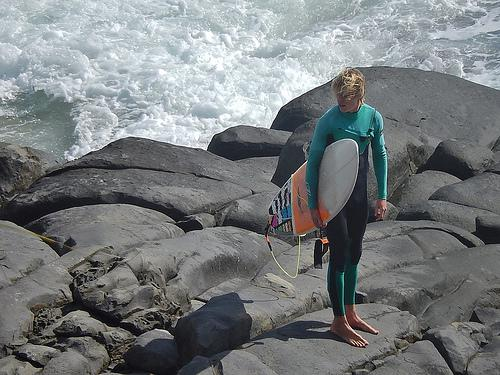Question: who is in the photo?
Choices:
A. The woman.
B. The man.
C. The children.
D. The dogs.
Answer with the letter. Answer: B Question: where is the man?
Choices:
A. On the rocks.
B. In the water.
C. On the moutain.
D. In the grass.
Answer with the letter. Answer: A Question: what color are the rocks?
Choices:
A. Red.
B. White.
C. Black.
D. Gray.
Answer with the letter. Answer: D Question: what is the man holding?
Choices:
A. A skateboard.
B. A surfboard.
C. A racket.
D. A ball.
Answer with the letter. Answer: B 